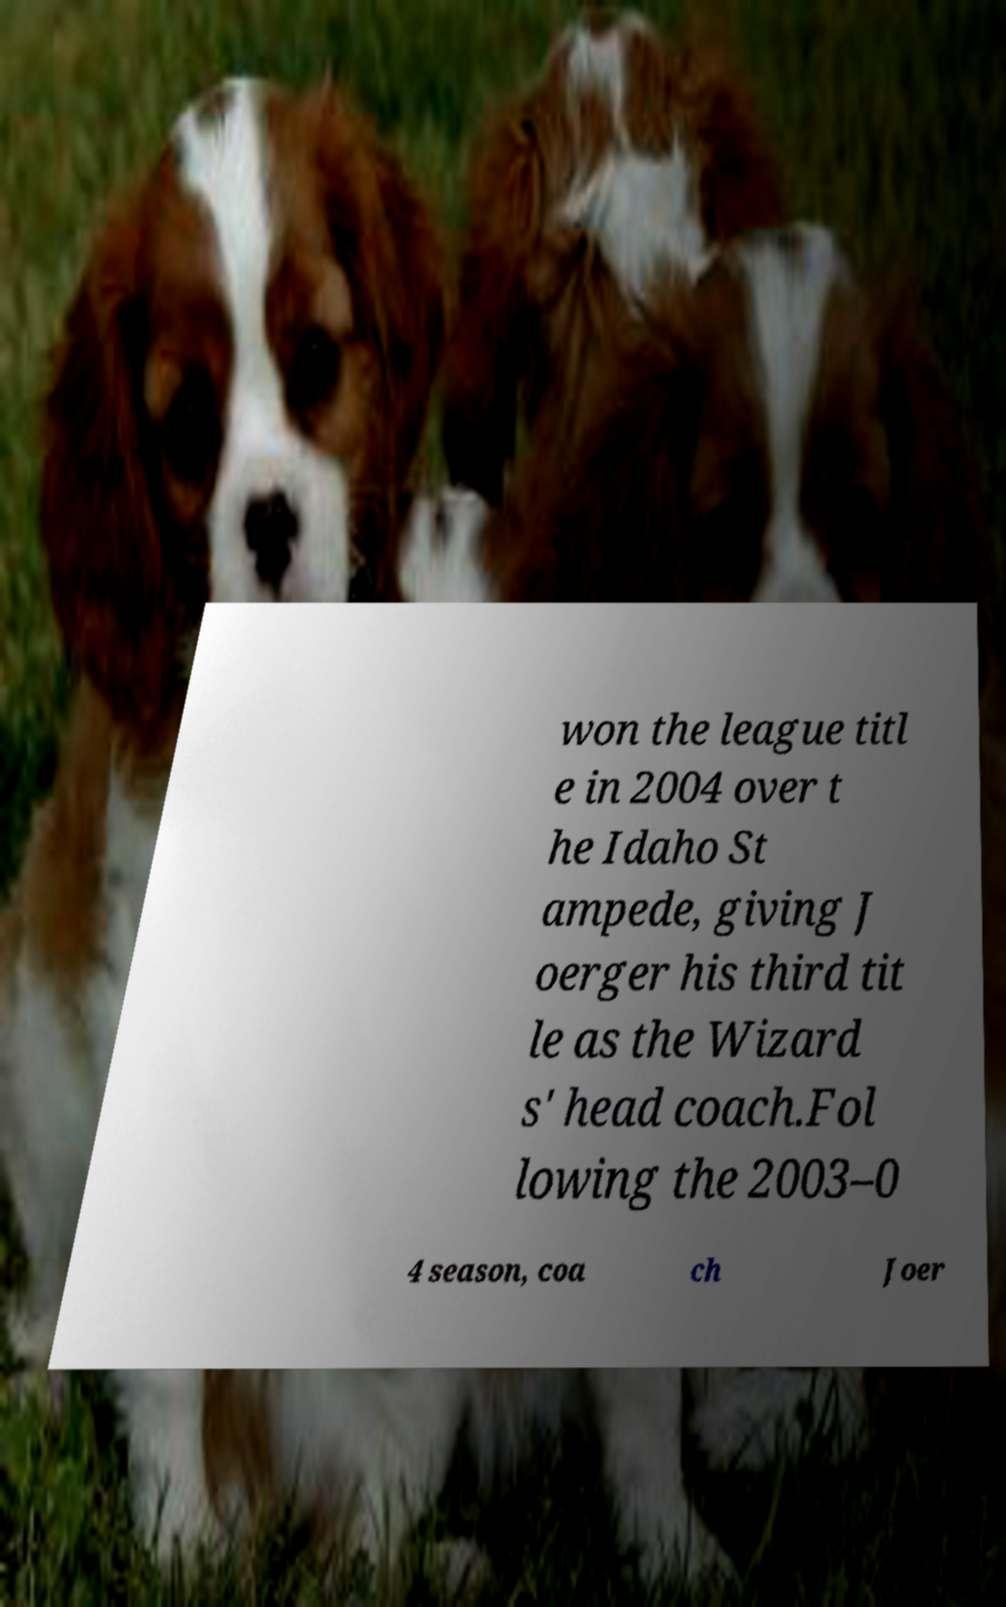What messages or text are displayed in this image? I need them in a readable, typed format. won the league titl e in 2004 over t he Idaho St ampede, giving J oerger his third tit le as the Wizard s' head coach.Fol lowing the 2003–0 4 season, coa ch Joer 